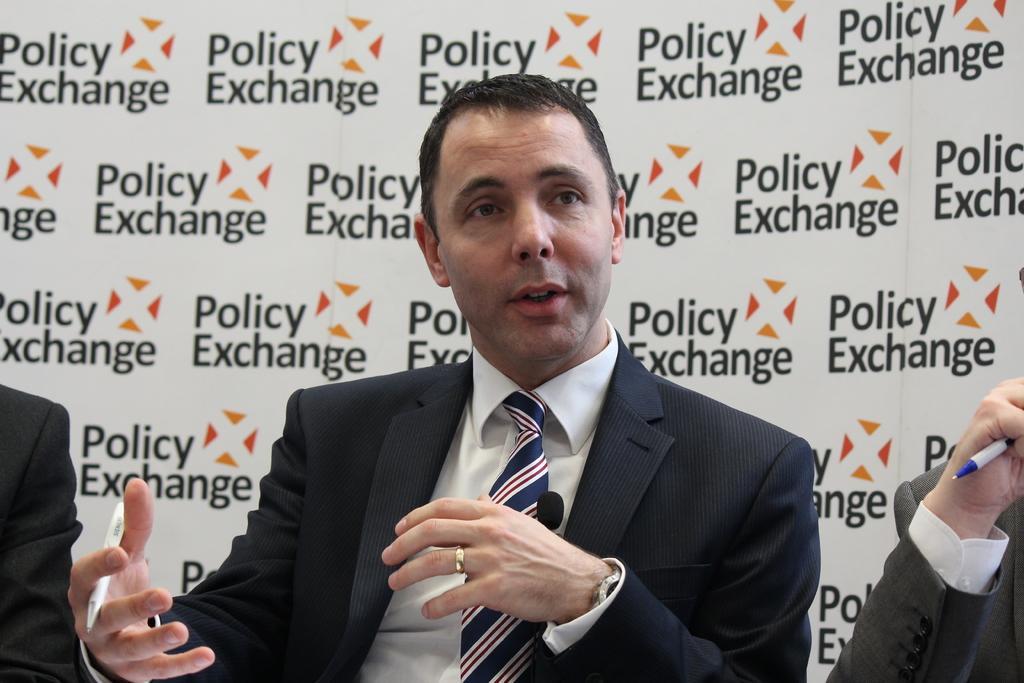Can you describe this image briefly? In this picture we can see three people and a man wore a blazer, tie, holding a pen with his hand and in the background we can see a banner. 